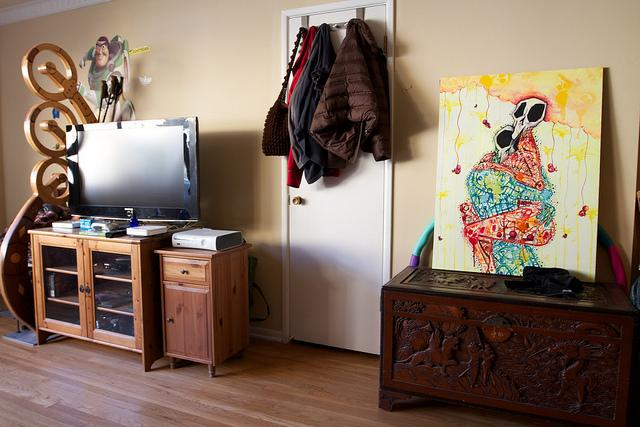What color is the coat jacket on the right side of the rack hung on the white door?

Choices:
A) brown
B) red
C) purple
D) black brown 